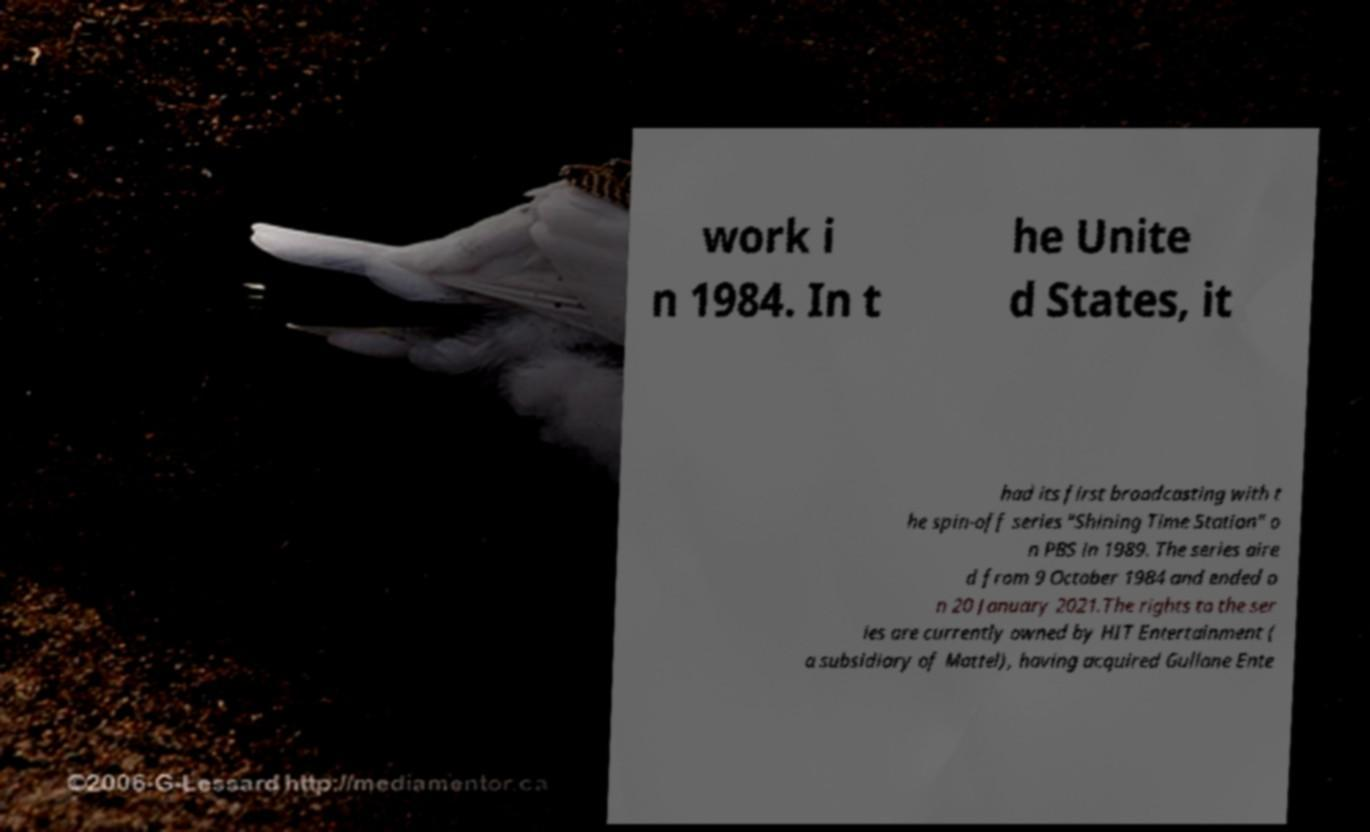Please read and relay the text visible in this image. What does it say? work i n 1984. In t he Unite d States, it had its first broadcasting with t he spin-off series "Shining Time Station" o n PBS in 1989. The series aire d from 9 October 1984 and ended o n 20 January 2021.The rights to the ser ies are currently owned by HIT Entertainment ( a subsidiary of Mattel), having acquired Gullane Ente 